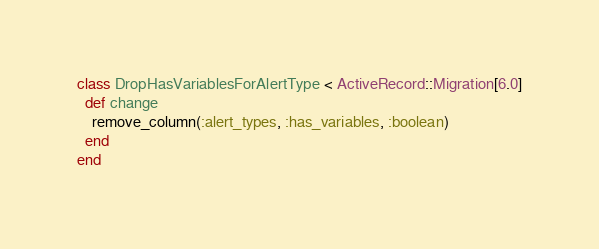<code> <loc_0><loc_0><loc_500><loc_500><_Ruby_>class DropHasVariablesForAlertType < ActiveRecord::Migration[6.0]
  def change
    remove_column(:alert_types, :has_variables, :boolean)
  end
end
</code> 